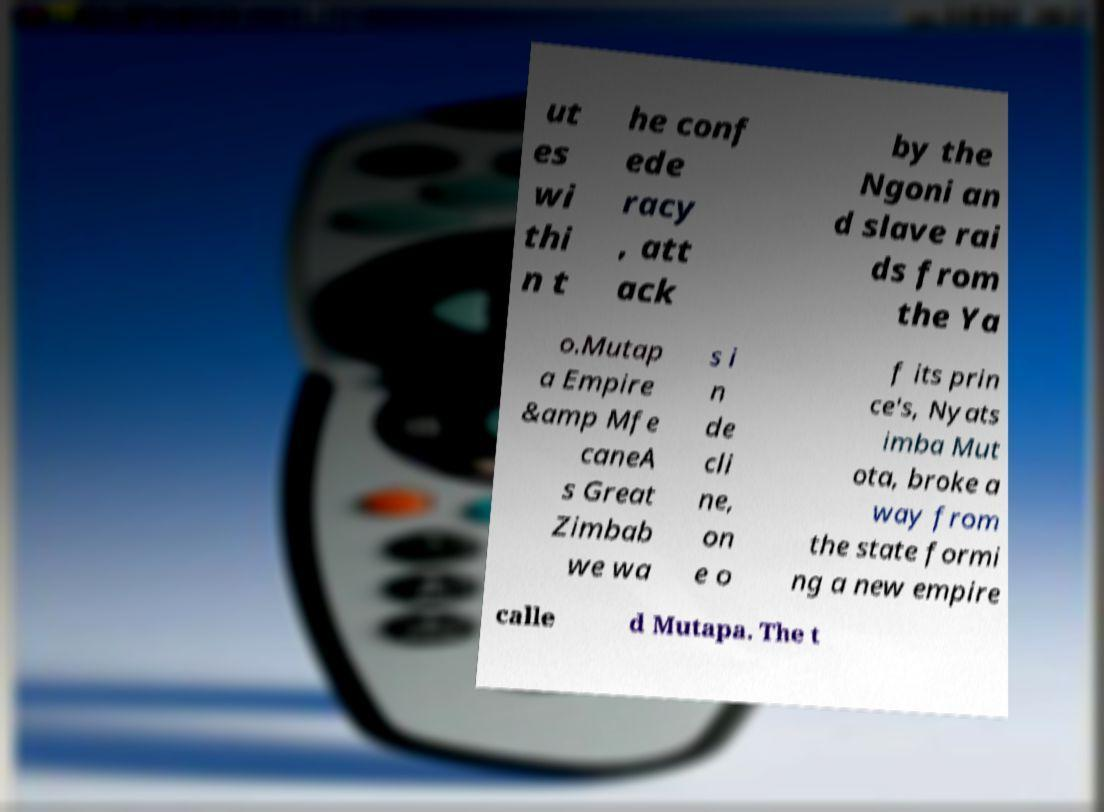Can you accurately transcribe the text from the provided image for me? ut es wi thi n t he conf ede racy , att ack by the Ngoni an d slave rai ds from the Ya o.Mutap a Empire &amp Mfe caneA s Great Zimbab we wa s i n de cli ne, on e o f its prin ce's, Nyats imba Mut ota, broke a way from the state formi ng a new empire calle d Mutapa. The t 